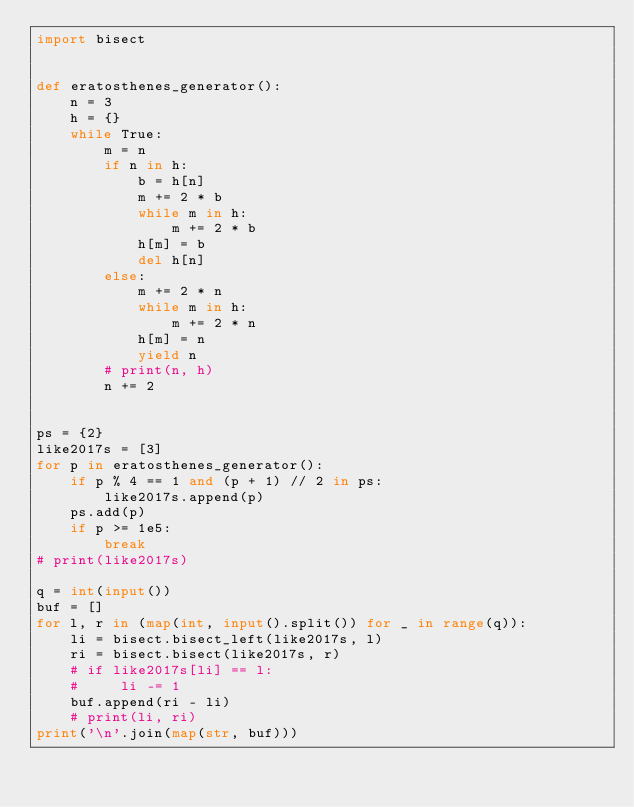<code> <loc_0><loc_0><loc_500><loc_500><_Python_>import bisect


def eratosthenes_generator():
    n = 3
    h = {}
    while True:
        m = n
        if n in h:
            b = h[n]
            m += 2 * b
            while m in h:
                m += 2 * b
            h[m] = b
            del h[n]
        else:
            m += 2 * n
            while m in h:
                m += 2 * n
            h[m] = n
            yield n
        # print(n, h)
        n += 2


ps = {2}
like2017s = [3]
for p in eratosthenes_generator():
    if p % 4 == 1 and (p + 1) // 2 in ps:
        like2017s.append(p)
    ps.add(p)
    if p >= 1e5:
        break
# print(like2017s)

q = int(input())
buf = []
for l, r in (map(int, input().split()) for _ in range(q)):
    li = bisect.bisect_left(like2017s, l)
    ri = bisect.bisect(like2017s, r)
    # if like2017s[li] == l:
    #     li -= 1
    buf.append(ri - li)
    # print(li, ri)
print('\n'.join(map(str, buf)))
</code> 